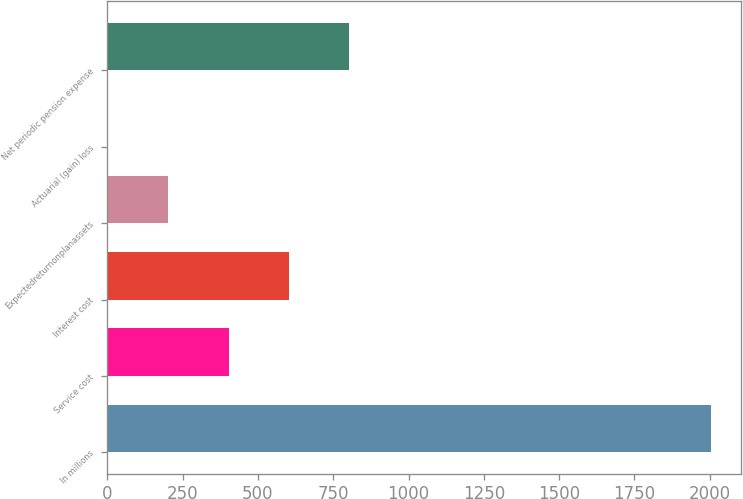<chart> <loc_0><loc_0><loc_500><loc_500><bar_chart><fcel>In millions<fcel>Service cost<fcel>Interest cost<fcel>Expectedreturnonplanassets<fcel>Actuarial (gain) loss<fcel>Net periodic pension expense<nl><fcel>2005<fcel>402.6<fcel>602.9<fcel>202.3<fcel>2<fcel>803.2<nl></chart> 